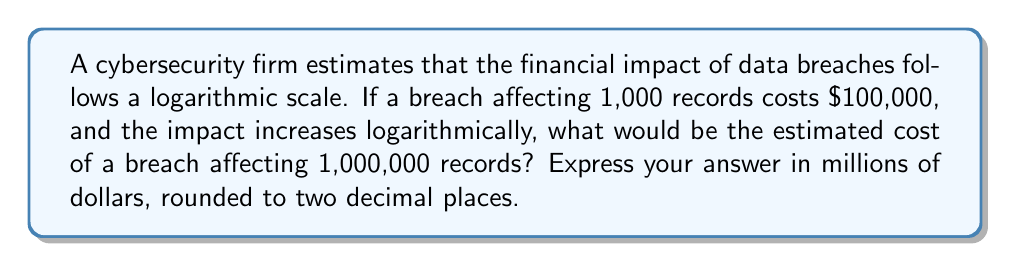Solve this math problem. To solve this problem, we need to use the properties of logarithmic scales. Let's approach this step-by-step:

1) Let's define our variables:
   $x$ = number of records
   $y$ = cost in dollars

2) We're told that when $x = 1,000$, $y = 100,000$

3) The logarithmic relationship can be expressed as:

   $y = a \log(x) + b$

   Where $a$ and $b$ are constants we need to determine.

4) We know one point: (1,000, 100,000). Let's use the common log (base 10) for simplicity:

   $100,000 = a \log(1,000) + b$
   $100,000 = 3a + b$  (since $\log(1,000) = 3$)

5) We need another equation to solve for $a$ and $b$. Let's use the fact that when $x = 1$, $y$ should be 0:

   $0 = a \log(1) + b$
   $0 = 0 + b$
   $b = 0$

6) Now we can solve for $a$:

   $100,000 = 3a + 0$
   $a = 33,333.33$

7) Our equation is now:

   $y = 33,333.33 \log(x)$

8) For 1,000,000 records:

   $y = 33,333.33 \log(1,000,000)$
   $y = 33,333.33 * 6$
   $y = 200,000$

9) Converting to millions and rounding to two decimal places:

   $200,000 / 1,000,000 = 0.20$
Answer: $0.20 million 